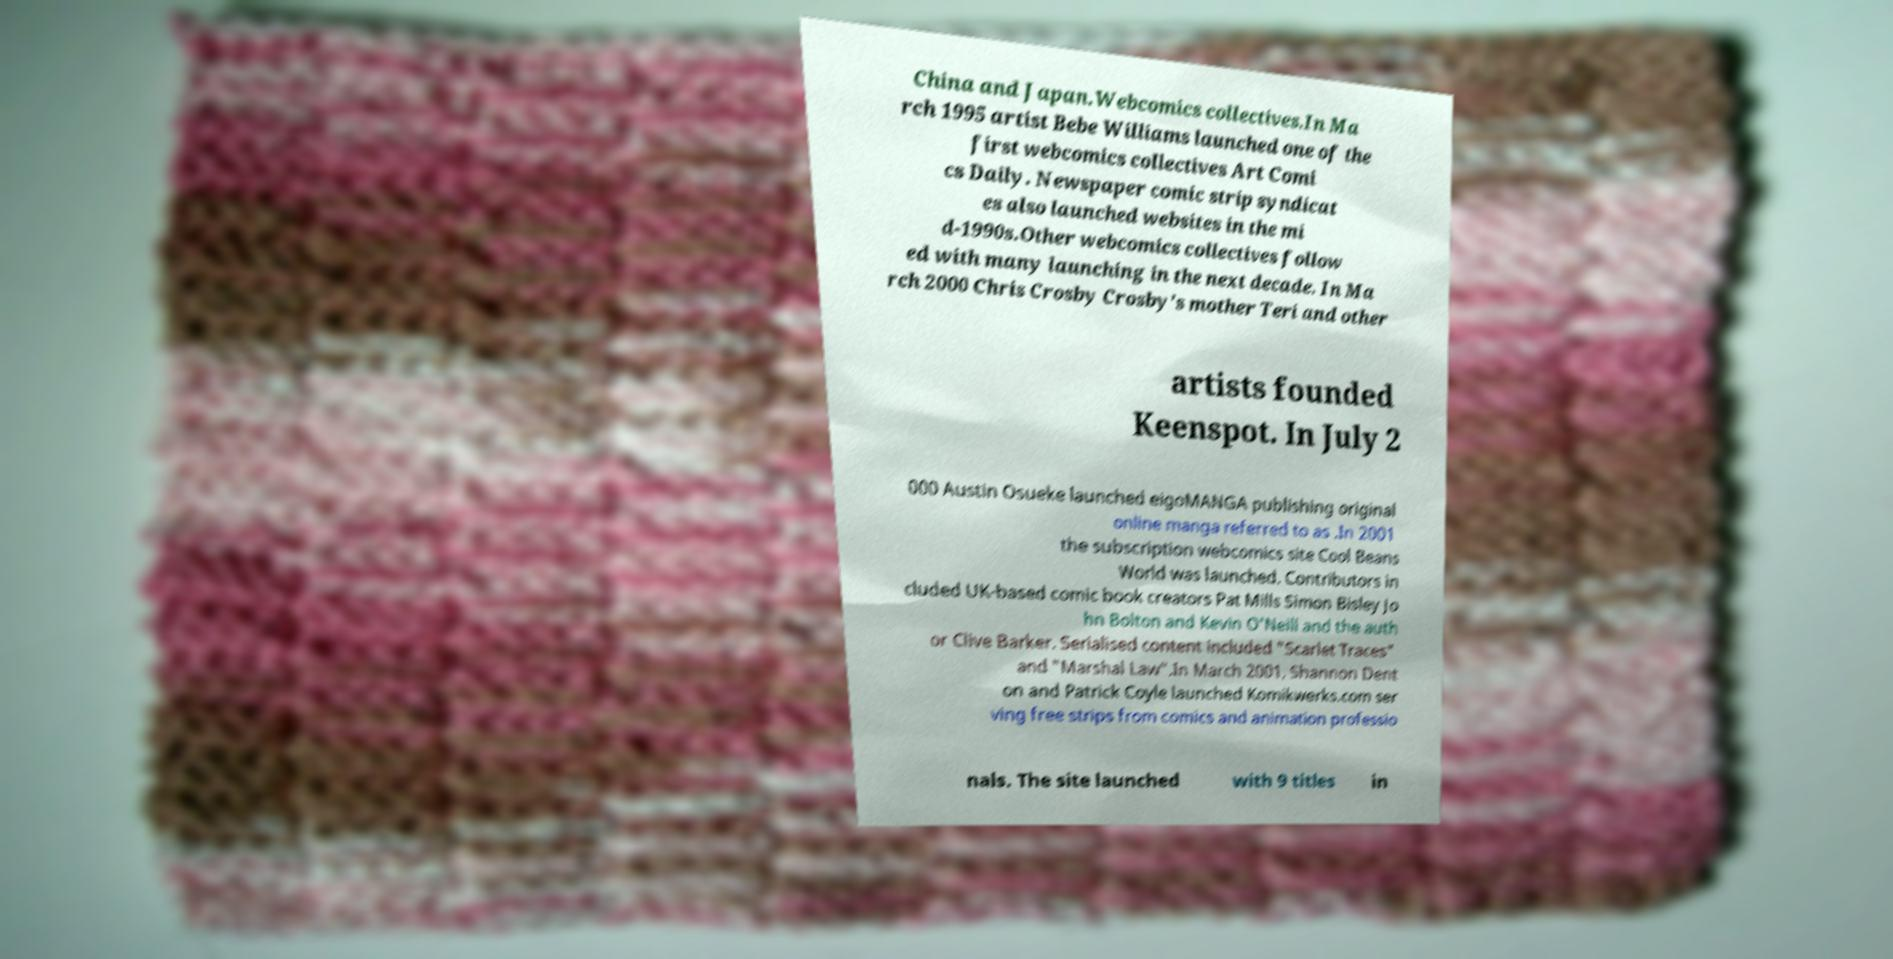Can you accurately transcribe the text from the provided image for me? China and Japan.Webcomics collectives.In Ma rch 1995 artist Bebe Williams launched one of the first webcomics collectives Art Comi cs Daily. Newspaper comic strip syndicat es also launched websites in the mi d-1990s.Other webcomics collectives follow ed with many launching in the next decade. In Ma rch 2000 Chris Crosby Crosby's mother Teri and other artists founded Keenspot. In July 2 000 Austin Osueke launched eigoMANGA publishing original online manga referred to as .In 2001 the subscription webcomics site Cool Beans World was launched. Contributors in cluded UK-based comic book creators Pat Mills Simon Bisley Jo hn Bolton and Kevin O'Neill and the auth or Clive Barker. Serialised content included "Scarlet Traces" and "Marshal Law".In March 2001, Shannon Dent on and Patrick Coyle launched Komikwerks.com ser ving free strips from comics and animation professio nals. The site launched with 9 titles in 